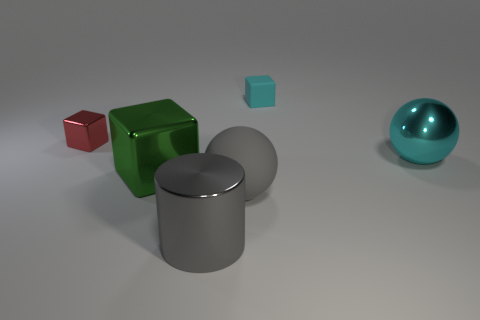What is the shape of the matte object that is the same color as the cylinder?
Offer a very short reply. Sphere. The rubber thing that is the same color as the metal ball is what size?
Your answer should be compact. Small. What number of gray things are either small matte cubes or shiny cylinders?
Offer a terse response. 1. What number of other things are there of the same shape as the red metallic thing?
Your response must be concise. 2. Do the large metallic object that is to the left of the big cylinder and the tiny block that is behind the tiny red thing have the same color?
Offer a terse response. No. How many large things are either gray balls or shiny balls?
Keep it short and to the point. 2. The red metallic thing that is the same shape as the large green thing is what size?
Make the answer very short. Small. What is the material of the block that is right of the ball left of the cyan rubber block?
Give a very brief answer. Rubber. What number of matte things are either small gray blocks or large green objects?
Provide a short and direct response. 0. There is a tiny matte object that is the same shape as the big green thing; what color is it?
Keep it short and to the point. Cyan. 